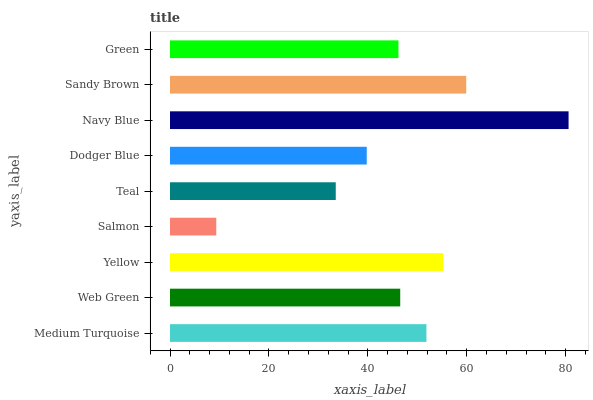Is Salmon the minimum?
Answer yes or no. Yes. Is Navy Blue the maximum?
Answer yes or no. Yes. Is Web Green the minimum?
Answer yes or no. No. Is Web Green the maximum?
Answer yes or no. No. Is Medium Turquoise greater than Web Green?
Answer yes or no. Yes. Is Web Green less than Medium Turquoise?
Answer yes or no. Yes. Is Web Green greater than Medium Turquoise?
Answer yes or no. No. Is Medium Turquoise less than Web Green?
Answer yes or no. No. Is Web Green the high median?
Answer yes or no. Yes. Is Web Green the low median?
Answer yes or no. Yes. Is Yellow the high median?
Answer yes or no. No. Is Navy Blue the low median?
Answer yes or no. No. 